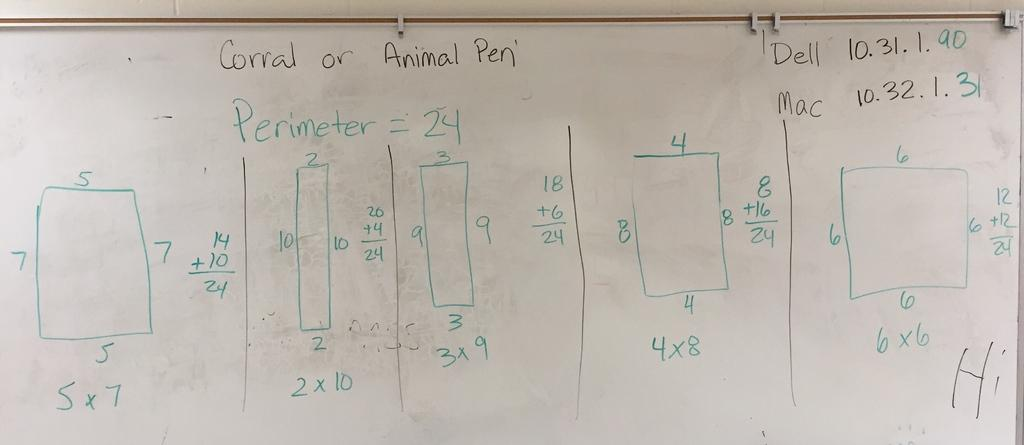What is the main object in the image? There is a board in the image. What can be found on the board? The board contains written words, numbers, and boxes. What type of pipe is connected to the board in the image? There is no pipe connected to the board in the image. What route does the rod take on the board in the image? There is no rod present on the board in the image. 